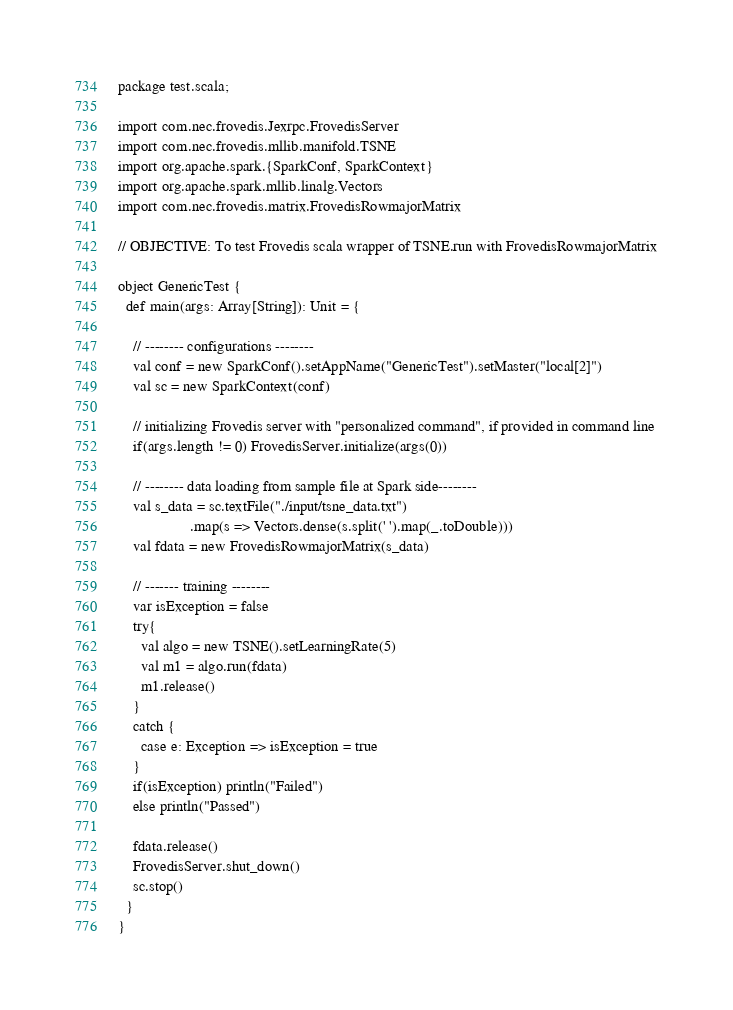<code> <loc_0><loc_0><loc_500><loc_500><_Scala_>package test.scala;

import com.nec.frovedis.Jexrpc.FrovedisServer
import com.nec.frovedis.mllib.manifold.TSNE
import org.apache.spark.{SparkConf, SparkContext}
import org.apache.spark.mllib.linalg.Vectors
import com.nec.frovedis.matrix.FrovedisRowmajorMatrix

// OBJECTIVE: To test Frovedis scala wrapper of TSNE.run with FrovedisRowmajorMatrix

object GenericTest {
  def main(args: Array[String]): Unit = {

    // -------- configurations --------
    val conf = new SparkConf().setAppName("GenericTest").setMaster("local[2]")
    val sc = new SparkContext(conf)

    // initializing Frovedis server with "personalized command", if provided in command line
    if(args.length != 0) FrovedisServer.initialize(args(0))

    // -------- data loading from sample file at Spark side--------
    val s_data = sc.textFile("./input/tsne_data.txt")
                   .map(s => Vectors.dense(s.split(' ').map(_.toDouble)))
    val fdata = new FrovedisRowmajorMatrix(s_data)

    // ------- training --------
    var isException = false
    try{
      val algo = new TSNE().setLearningRate(5)
      val m1 = algo.run(fdata)
      m1.release()
    }
    catch {
      case e: Exception => isException = true
    }
    if(isException) println("Failed")
    else println("Passed")

    fdata.release()
    FrovedisServer.shut_down()
    sc.stop()
  }
}
</code> 